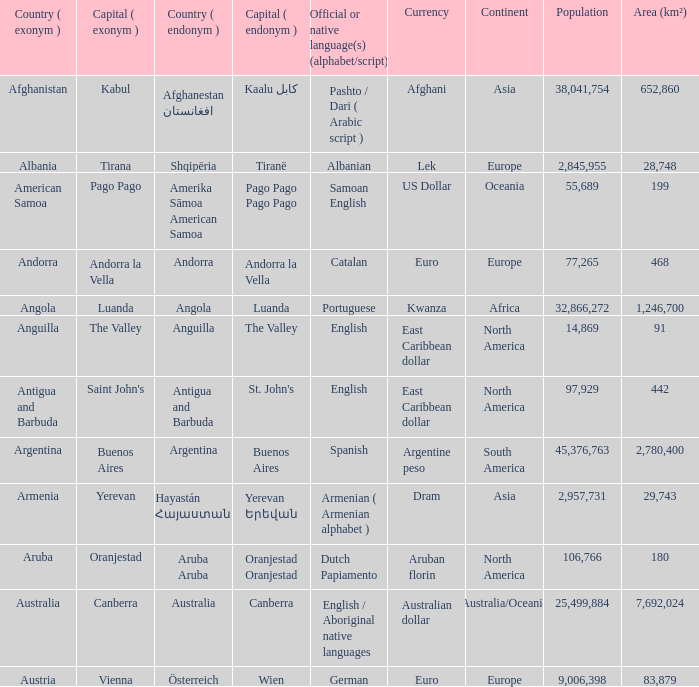What is the English name given to the city of St. John's? Saint John's. 